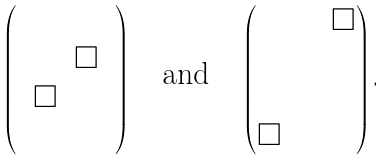<formula> <loc_0><loc_0><loc_500><loc_500>\begin{pmatrix} & & & \\ & & \Box & \\ & \Box & & \\ & & & \\ \end{pmatrix} \quad \text {and} \quad \begin{pmatrix} & & & \Box \\ & & & \\ & & & \\ \Box & & & \\ \end{pmatrix} ,</formula> 